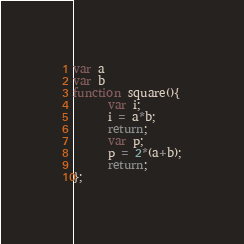<code> <loc_0><loc_0><loc_500><loc_500><_JavaScript_>var a
var b
function square(){
      var i;
      i = a*b;
      return;
      var p;
      p = 2*(a+b);
      return;
};</code> 